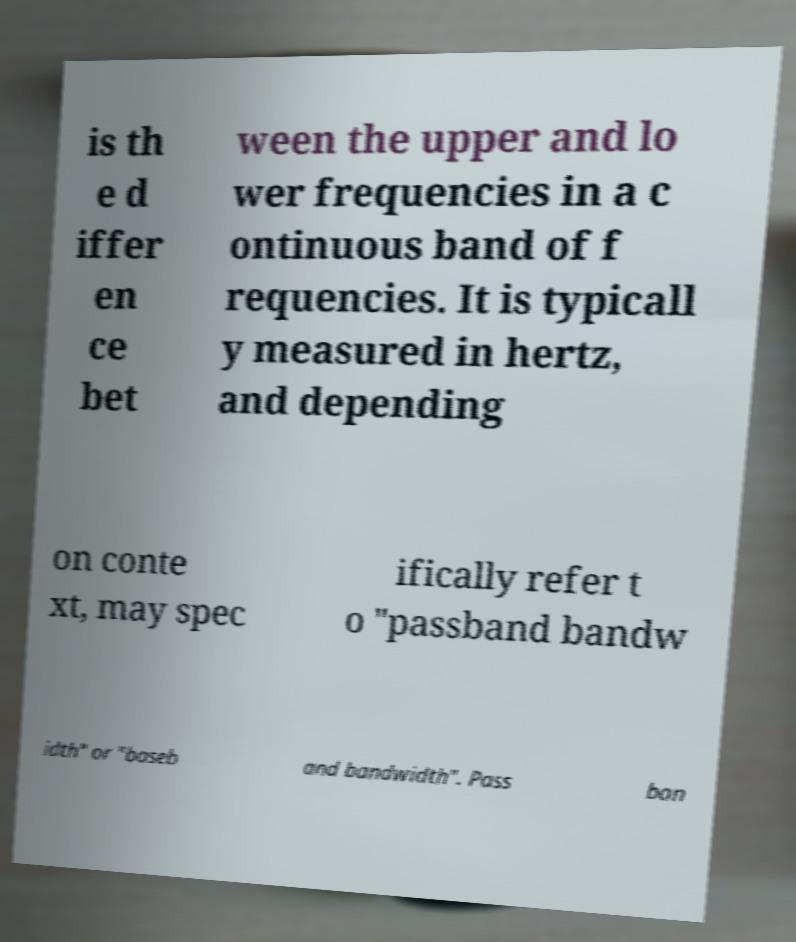For documentation purposes, I need the text within this image transcribed. Could you provide that? is th e d iffer en ce bet ween the upper and lo wer frequencies in a c ontinuous band of f requencies. It is typicall y measured in hertz, and depending on conte xt, may spec ifically refer t o "passband bandw idth" or "baseb and bandwidth". Pass ban 